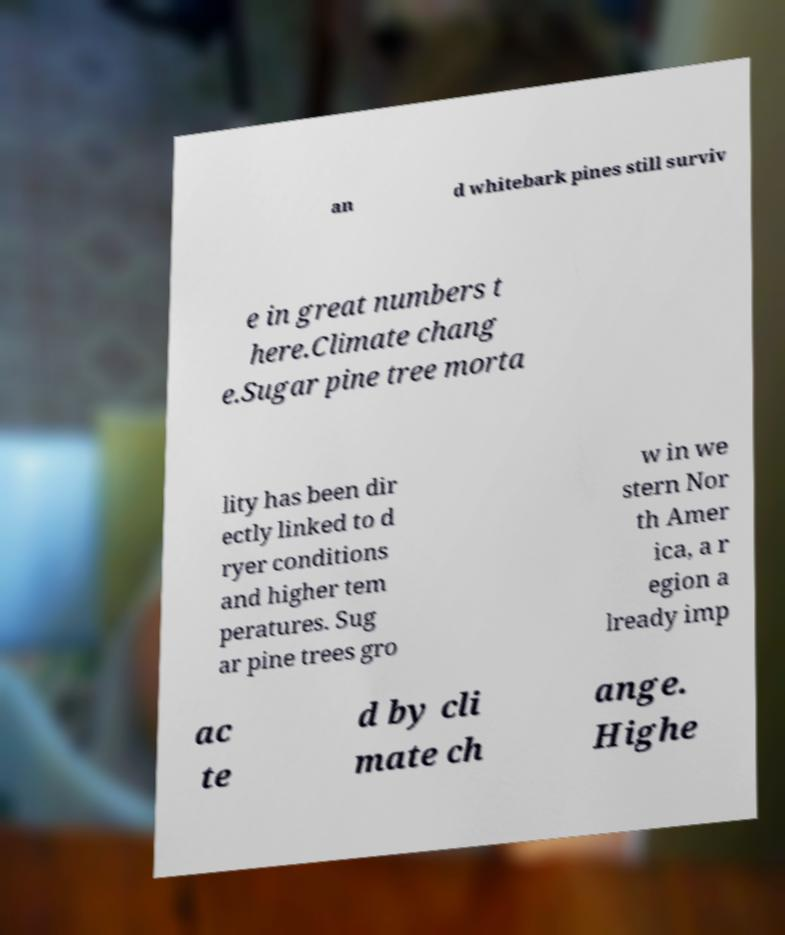Could you assist in decoding the text presented in this image and type it out clearly? an d whitebark pines still surviv e in great numbers t here.Climate chang e.Sugar pine tree morta lity has been dir ectly linked to d ryer conditions and higher tem peratures. Sug ar pine trees gro w in we stern Nor th Amer ica, a r egion a lready imp ac te d by cli mate ch ange. Highe 